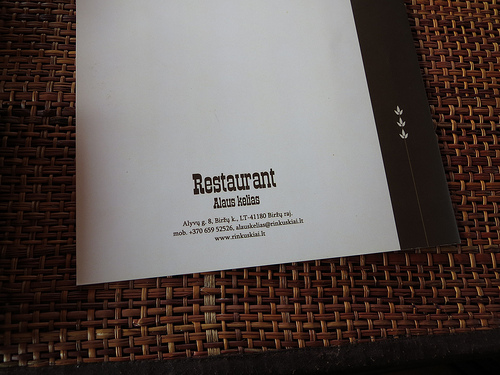<image>
Can you confirm if the menu is on the wood? Yes. Looking at the image, I can see the menu is positioned on top of the wood, with the wood providing support. 